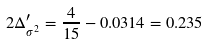Convert formula to latex. <formula><loc_0><loc_0><loc_500><loc_500>2 \Delta _ { \sigma ^ { 2 } } ^ { \prime } = \frac { 4 } { 1 5 } - 0 . 0 3 1 4 = 0 . 2 3 5</formula> 